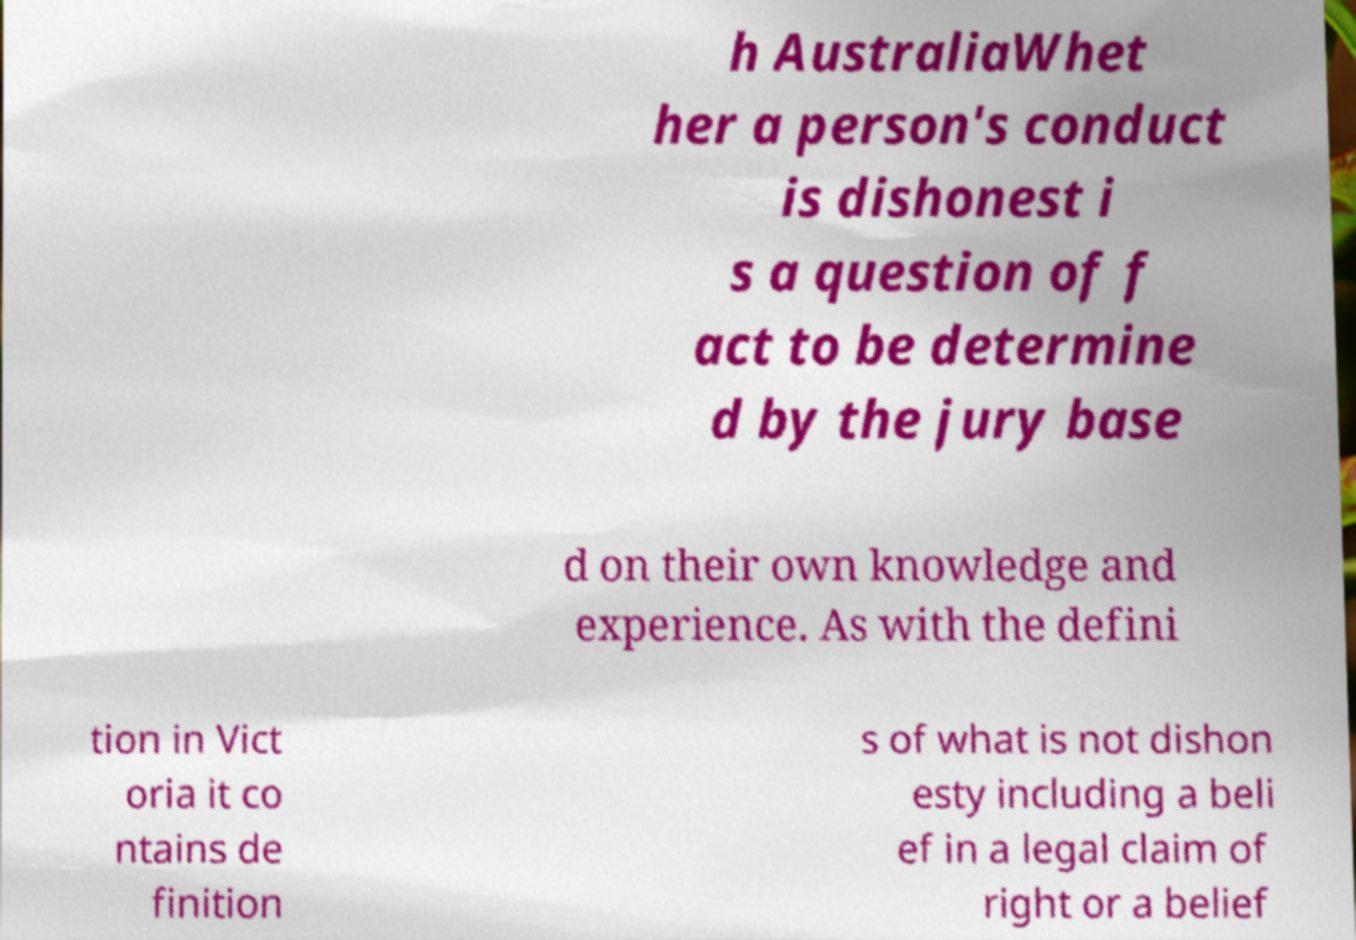Could you assist in decoding the text presented in this image and type it out clearly? h AustraliaWhet her a person's conduct is dishonest i s a question of f act to be determine d by the jury base d on their own knowledge and experience. As with the defini tion in Vict oria it co ntains de finition s of what is not dishon esty including a beli ef in a legal claim of right or a belief 